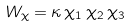Convert formula to latex. <formula><loc_0><loc_0><loc_500><loc_500>W _ { \chi } = \kappa \, \chi _ { 1 } \, \chi _ { 2 } \, \chi _ { 3 }</formula> 